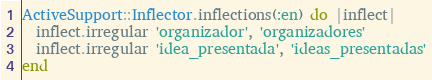<code> <loc_0><loc_0><loc_500><loc_500><_Ruby_>ActiveSupport::Inflector.inflections(:en) do |inflect|
  inflect.irregular 'organizador', 'organizadores'
  inflect.irregular 'idea_presentada', 'ideas_presentadas'
end
</code> 